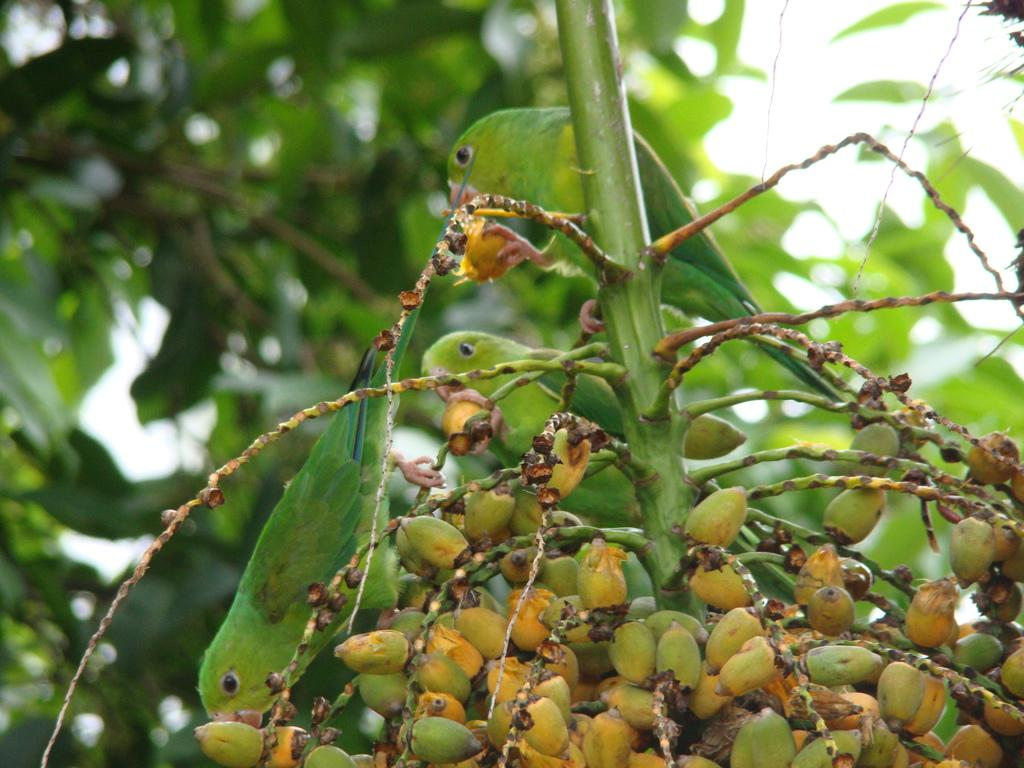What animals are in the center of the image? There are parrots in the center of the image. Where are the parrots located? The parrots are on a stem. What type of plant is visible at the bottom of the image? There is a coconut palm at the bottom of the image. What can be seen in the background of the image? Trees and the sky are visible in the background of the image. Can you recite the verse that the parrots are singing in the image? There is no indication in the image that the parrots are singing or reciting a verse, so it cannot be determined from the picture. 